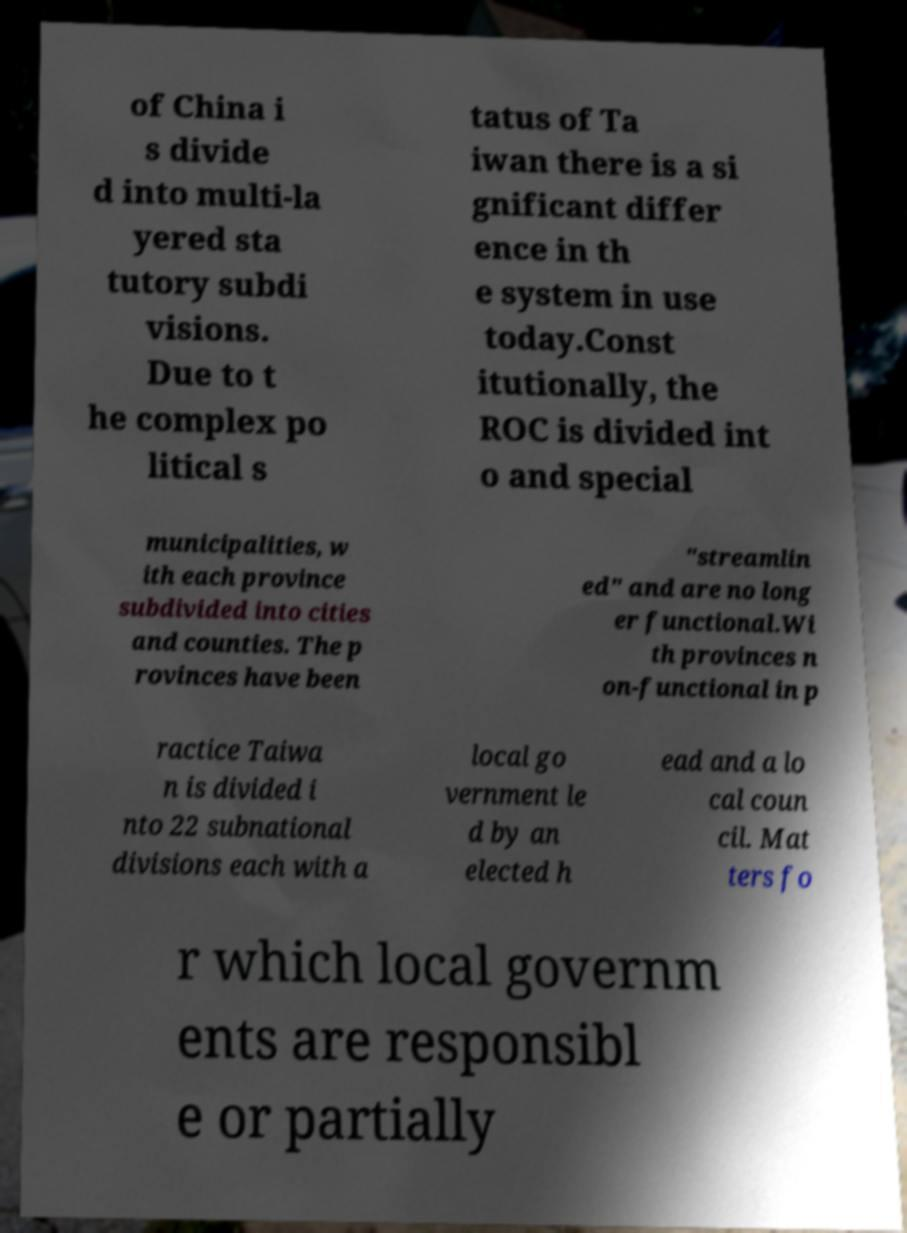Can you accurately transcribe the text from the provided image for me? of China i s divide d into multi-la yered sta tutory subdi visions. Due to t he complex po litical s tatus of Ta iwan there is a si gnificant differ ence in th e system in use today.Const itutionally, the ROC is divided int o and special municipalities, w ith each province subdivided into cities and counties. The p rovinces have been "streamlin ed" and are no long er functional.Wi th provinces n on-functional in p ractice Taiwa n is divided i nto 22 subnational divisions each with a local go vernment le d by an elected h ead and a lo cal coun cil. Mat ters fo r which local governm ents are responsibl e or partially 